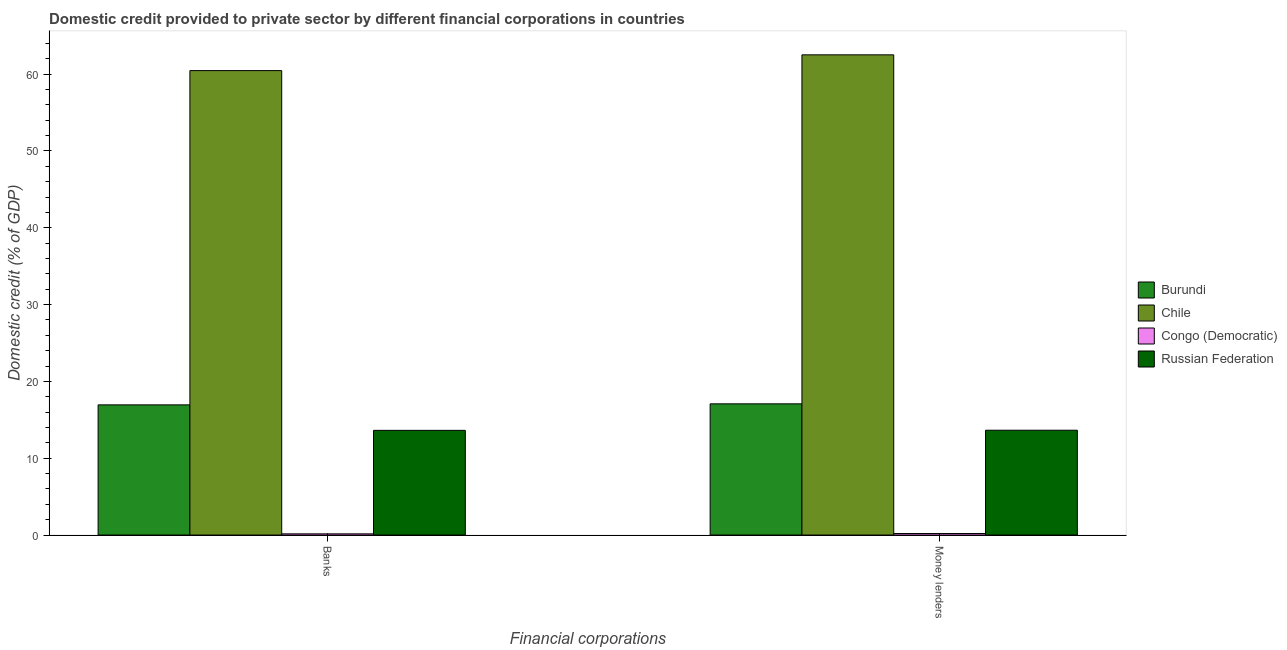How many different coloured bars are there?
Offer a very short reply. 4. How many bars are there on the 1st tick from the left?
Provide a short and direct response. 4. How many bars are there on the 2nd tick from the right?
Ensure brevity in your answer.  4. What is the label of the 2nd group of bars from the left?
Offer a terse response. Money lenders. What is the domestic credit provided by banks in Congo (Democratic)?
Provide a succinct answer. 0.15. Across all countries, what is the maximum domestic credit provided by money lenders?
Your answer should be very brief. 62.52. Across all countries, what is the minimum domestic credit provided by banks?
Offer a very short reply. 0.15. In which country was the domestic credit provided by money lenders maximum?
Your answer should be very brief. Chile. In which country was the domestic credit provided by money lenders minimum?
Ensure brevity in your answer.  Congo (Democratic). What is the total domestic credit provided by money lenders in the graph?
Your answer should be compact. 93.44. What is the difference between the domestic credit provided by money lenders in Chile and that in Russian Federation?
Offer a terse response. 48.87. What is the difference between the domestic credit provided by money lenders in Congo (Democratic) and the domestic credit provided by banks in Burundi?
Offer a very short reply. -16.75. What is the average domestic credit provided by money lenders per country?
Your answer should be very brief. 23.36. What is the difference between the domestic credit provided by money lenders and domestic credit provided by banks in Burundi?
Offer a terse response. 0.13. What is the ratio of the domestic credit provided by money lenders in Congo (Democratic) to that in Burundi?
Provide a succinct answer. 0.01. Is the domestic credit provided by banks in Chile less than that in Burundi?
Your response must be concise. No. In how many countries, is the domestic credit provided by banks greater than the average domestic credit provided by banks taken over all countries?
Give a very brief answer. 1. What does the 1st bar from the left in Banks represents?
Give a very brief answer. Burundi. What does the 3rd bar from the right in Money lenders represents?
Ensure brevity in your answer.  Chile. How many bars are there?
Your response must be concise. 8. Are all the bars in the graph horizontal?
Your response must be concise. No. Does the graph contain any zero values?
Ensure brevity in your answer.  No. Does the graph contain grids?
Your response must be concise. No. How are the legend labels stacked?
Your response must be concise. Vertical. What is the title of the graph?
Provide a short and direct response. Domestic credit provided to private sector by different financial corporations in countries. What is the label or title of the X-axis?
Make the answer very short. Financial corporations. What is the label or title of the Y-axis?
Your answer should be very brief. Domestic credit (% of GDP). What is the Domestic credit (% of GDP) in Burundi in Banks?
Keep it short and to the point. 16.95. What is the Domestic credit (% of GDP) of Chile in Banks?
Your answer should be very brief. 60.47. What is the Domestic credit (% of GDP) in Congo (Democratic) in Banks?
Provide a succinct answer. 0.15. What is the Domestic credit (% of GDP) in Russian Federation in Banks?
Give a very brief answer. 13.63. What is the Domestic credit (% of GDP) of Burundi in Money lenders?
Your answer should be very brief. 17.08. What is the Domestic credit (% of GDP) of Chile in Money lenders?
Keep it short and to the point. 62.52. What is the Domestic credit (% of GDP) in Congo (Democratic) in Money lenders?
Your response must be concise. 0.2. What is the Domestic credit (% of GDP) in Russian Federation in Money lenders?
Offer a very short reply. 13.65. Across all Financial corporations, what is the maximum Domestic credit (% of GDP) of Burundi?
Keep it short and to the point. 17.08. Across all Financial corporations, what is the maximum Domestic credit (% of GDP) of Chile?
Give a very brief answer. 62.52. Across all Financial corporations, what is the maximum Domestic credit (% of GDP) of Congo (Democratic)?
Offer a terse response. 0.2. Across all Financial corporations, what is the maximum Domestic credit (% of GDP) in Russian Federation?
Your answer should be very brief. 13.65. Across all Financial corporations, what is the minimum Domestic credit (% of GDP) in Burundi?
Provide a short and direct response. 16.95. Across all Financial corporations, what is the minimum Domestic credit (% of GDP) in Chile?
Your answer should be compact. 60.47. Across all Financial corporations, what is the minimum Domestic credit (% of GDP) of Congo (Democratic)?
Your answer should be compact. 0.15. Across all Financial corporations, what is the minimum Domestic credit (% of GDP) in Russian Federation?
Offer a very short reply. 13.63. What is the total Domestic credit (% of GDP) of Burundi in the graph?
Your answer should be very brief. 34.03. What is the total Domestic credit (% of GDP) of Chile in the graph?
Provide a short and direct response. 122.99. What is the total Domestic credit (% of GDP) in Congo (Democratic) in the graph?
Your answer should be compact. 0.35. What is the total Domestic credit (% of GDP) of Russian Federation in the graph?
Your answer should be compact. 27.28. What is the difference between the Domestic credit (% of GDP) in Burundi in Banks and that in Money lenders?
Your answer should be compact. -0.13. What is the difference between the Domestic credit (% of GDP) in Chile in Banks and that in Money lenders?
Ensure brevity in your answer.  -2.05. What is the difference between the Domestic credit (% of GDP) in Congo (Democratic) in Banks and that in Money lenders?
Your answer should be very brief. -0.04. What is the difference between the Domestic credit (% of GDP) of Russian Federation in Banks and that in Money lenders?
Give a very brief answer. -0.02. What is the difference between the Domestic credit (% of GDP) in Burundi in Banks and the Domestic credit (% of GDP) in Chile in Money lenders?
Keep it short and to the point. -45.57. What is the difference between the Domestic credit (% of GDP) of Burundi in Banks and the Domestic credit (% of GDP) of Congo (Democratic) in Money lenders?
Offer a very short reply. 16.75. What is the difference between the Domestic credit (% of GDP) of Burundi in Banks and the Domestic credit (% of GDP) of Russian Federation in Money lenders?
Ensure brevity in your answer.  3.3. What is the difference between the Domestic credit (% of GDP) in Chile in Banks and the Domestic credit (% of GDP) in Congo (Democratic) in Money lenders?
Keep it short and to the point. 60.27. What is the difference between the Domestic credit (% of GDP) in Chile in Banks and the Domestic credit (% of GDP) in Russian Federation in Money lenders?
Provide a succinct answer. 46.82. What is the difference between the Domestic credit (% of GDP) in Congo (Democratic) in Banks and the Domestic credit (% of GDP) in Russian Federation in Money lenders?
Your answer should be compact. -13.49. What is the average Domestic credit (% of GDP) of Burundi per Financial corporations?
Keep it short and to the point. 17.01. What is the average Domestic credit (% of GDP) in Chile per Financial corporations?
Your response must be concise. 61.49. What is the average Domestic credit (% of GDP) in Congo (Democratic) per Financial corporations?
Give a very brief answer. 0.18. What is the average Domestic credit (% of GDP) of Russian Federation per Financial corporations?
Give a very brief answer. 13.64. What is the difference between the Domestic credit (% of GDP) in Burundi and Domestic credit (% of GDP) in Chile in Banks?
Provide a succinct answer. -43.52. What is the difference between the Domestic credit (% of GDP) in Burundi and Domestic credit (% of GDP) in Congo (Democratic) in Banks?
Your answer should be compact. 16.79. What is the difference between the Domestic credit (% of GDP) of Burundi and Domestic credit (% of GDP) of Russian Federation in Banks?
Ensure brevity in your answer.  3.32. What is the difference between the Domestic credit (% of GDP) in Chile and Domestic credit (% of GDP) in Congo (Democratic) in Banks?
Provide a succinct answer. 60.31. What is the difference between the Domestic credit (% of GDP) in Chile and Domestic credit (% of GDP) in Russian Federation in Banks?
Your answer should be compact. 46.84. What is the difference between the Domestic credit (% of GDP) of Congo (Democratic) and Domestic credit (% of GDP) of Russian Federation in Banks?
Offer a terse response. -13.48. What is the difference between the Domestic credit (% of GDP) of Burundi and Domestic credit (% of GDP) of Chile in Money lenders?
Keep it short and to the point. -45.44. What is the difference between the Domestic credit (% of GDP) in Burundi and Domestic credit (% of GDP) in Congo (Democratic) in Money lenders?
Give a very brief answer. 16.88. What is the difference between the Domestic credit (% of GDP) of Burundi and Domestic credit (% of GDP) of Russian Federation in Money lenders?
Your answer should be very brief. 3.43. What is the difference between the Domestic credit (% of GDP) of Chile and Domestic credit (% of GDP) of Congo (Democratic) in Money lenders?
Ensure brevity in your answer.  62.32. What is the difference between the Domestic credit (% of GDP) in Chile and Domestic credit (% of GDP) in Russian Federation in Money lenders?
Make the answer very short. 48.87. What is the difference between the Domestic credit (% of GDP) of Congo (Democratic) and Domestic credit (% of GDP) of Russian Federation in Money lenders?
Make the answer very short. -13.45. What is the ratio of the Domestic credit (% of GDP) of Chile in Banks to that in Money lenders?
Ensure brevity in your answer.  0.97. What is the ratio of the Domestic credit (% of GDP) in Congo (Democratic) in Banks to that in Money lenders?
Ensure brevity in your answer.  0.78. What is the difference between the highest and the second highest Domestic credit (% of GDP) in Burundi?
Offer a terse response. 0.13. What is the difference between the highest and the second highest Domestic credit (% of GDP) of Chile?
Your response must be concise. 2.05. What is the difference between the highest and the second highest Domestic credit (% of GDP) in Congo (Democratic)?
Provide a short and direct response. 0.04. What is the difference between the highest and the second highest Domestic credit (% of GDP) in Russian Federation?
Make the answer very short. 0.02. What is the difference between the highest and the lowest Domestic credit (% of GDP) of Burundi?
Provide a succinct answer. 0.13. What is the difference between the highest and the lowest Domestic credit (% of GDP) in Chile?
Your answer should be very brief. 2.05. What is the difference between the highest and the lowest Domestic credit (% of GDP) of Congo (Democratic)?
Your answer should be very brief. 0.04. What is the difference between the highest and the lowest Domestic credit (% of GDP) of Russian Federation?
Your answer should be very brief. 0.02. 